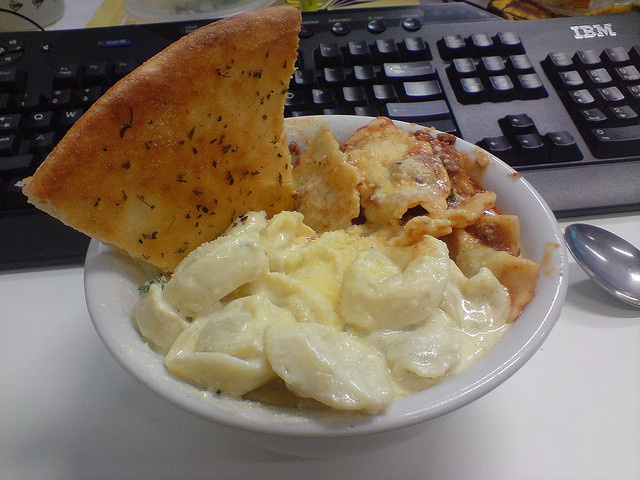Describe the objects in this image and their specific colors. I can see dining table in gray, darkgray, and lightgray tones, keyboard in gray, black, and navy tones, pizza in gray, maroon, and olive tones, bowl in gray, darkgray, and olive tones, and spoon in gray and lightgray tones in this image. 